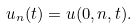Convert formula to latex. <formula><loc_0><loc_0><loc_500><loc_500>u _ { n } ( t ) = u ( 0 , n , t ) .</formula> 